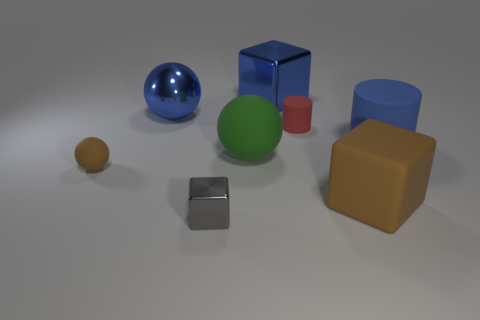Is the color of the big matte cube the same as the tiny matte sphere?
Your response must be concise. Yes. How big is the shiny block that is in front of the brown rubber sphere?
Provide a short and direct response. Small. Do the rubber cylinder right of the red object and the big thing on the left side of the green matte thing have the same color?
Your response must be concise. Yes. How many other objects are the same shape as the tiny gray object?
Your answer should be compact. 2. Are there the same number of blue rubber things in front of the small brown ball and metal cubes that are in front of the big green object?
Your answer should be compact. No. Do the big block that is in front of the small cylinder and the big object that is to the left of the gray metal block have the same material?
Offer a terse response. No. What number of other things are there of the same size as the green sphere?
Keep it short and to the point. 4. What number of objects are big green matte spheres or rubber objects that are in front of the big blue rubber cylinder?
Your answer should be very brief. 3. Is the number of big metal cubes that are behind the small metallic thing the same as the number of blocks?
Provide a short and direct response. No. What is the shape of the blue thing that is made of the same material as the brown sphere?
Provide a short and direct response. Cylinder. 